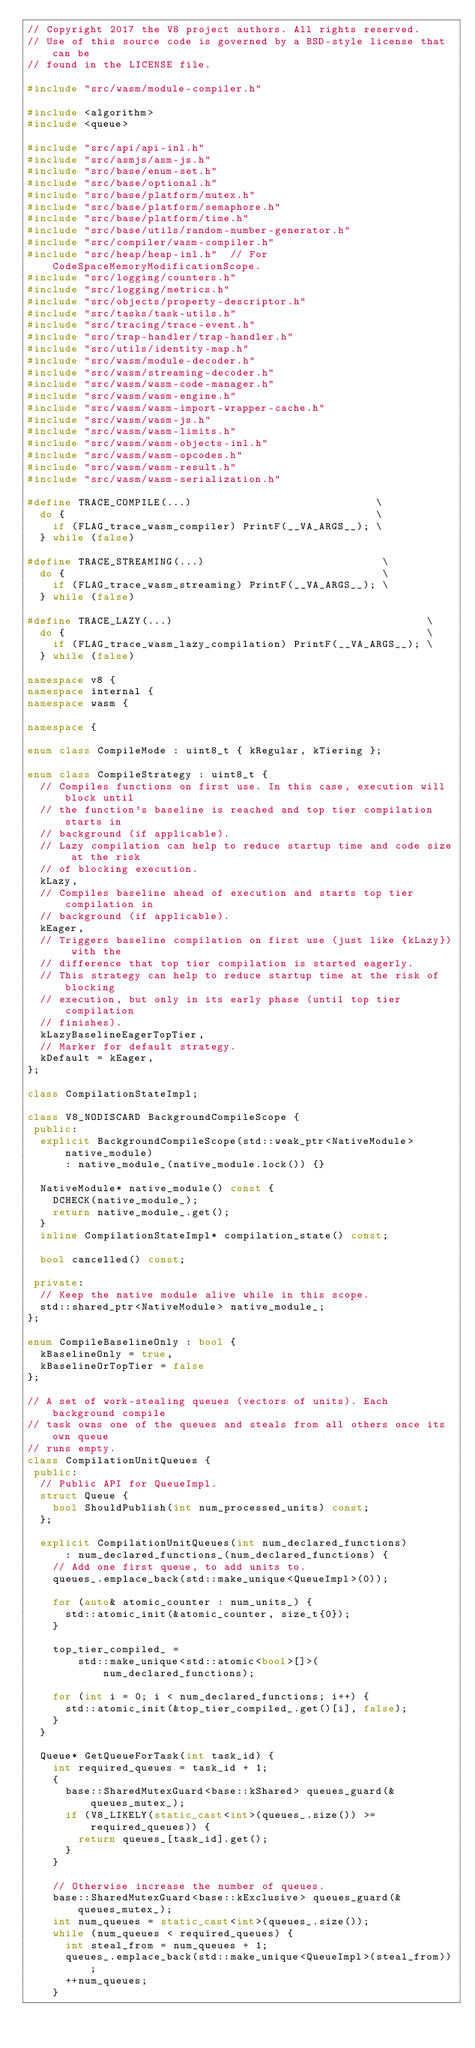<code> <loc_0><loc_0><loc_500><loc_500><_C++_>// Copyright 2017 the V8 project authors. All rights reserved.
// Use of this source code is governed by a BSD-style license that can be
// found in the LICENSE file.

#include "src/wasm/module-compiler.h"

#include <algorithm>
#include <queue>

#include "src/api/api-inl.h"
#include "src/asmjs/asm-js.h"
#include "src/base/enum-set.h"
#include "src/base/optional.h"
#include "src/base/platform/mutex.h"
#include "src/base/platform/semaphore.h"
#include "src/base/platform/time.h"
#include "src/base/utils/random-number-generator.h"
#include "src/compiler/wasm-compiler.h"
#include "src/heap/heap-inl.h"  // For CodeSpaceMemoryModificationScope.
#include "src/logging/counters.h"
#include "src/logging/metrics.h"
#include "src/objects/property-descriptor.h"
#include "src/tasks/task-utils.h"
#include "src/tracing/trace-event.h"
#include "src/trap-handler/trap-handler.h"
#include "src/utils/identity-map.h"
#include "src/wasm/module-decoder.h"
#include "src/wasm/streaming-decoder.h"
#include "src/wasm/wasm-code-manager.h"
#include "src/wasm/wasm-engine.h"
#include "src/wasm/wasm-import-wrapper-cache.h"
#include "src/wasm/wasm-js.h"
#include "src/wasm/wasm-limits.h"
#include "src/wasm/wasm-objects-inl.h"
#include "src/wasm/wasm-opcodes.h"
#include "src/wasm/wasm-result.h"
#include "src/wasm/wasm-serialization.h"

#define TRACE_COMPILE(...)                             \
  do {                                                 \
    if (FLAG_trace_wasm_compiler) PrintF(__VA_ARGS__); \
  } while (false)

#define TRACE_STREAMING(...)                            \
  do {                                                  \
    if (FLAG_trace_wasm_streaming) PrintF(__VA_ARGS__); \
  } while (false)

#define TRACE_LAZY(...)                                        \
  do {                                                         \
    if (FLAG_trace_wasm_lazy_compilation) PrintF(__VA_ARGS__); \
  } while (false)

namespace v8 {
namespace internal {
namespace wasm {

namespace {

enum class CompileMode : uint8_t { kRegular, kTiering };

enum class CompileStrategy : uint8_t {
  // Compiles functions on first use. In this case, execution will block until
  // the function's baseline is reached and top tier compilation starts in
  // background (if applicable).
  // Lazy compilation can help to reduce startup time and code size at the risk
  // of blocking execution.
  kLazy,
  // Compiles baseline ahead of execution and starts top tier compilation in
  // background (if applicable).
  kEager,
  // Triggers baseline compilation on first use (just like {kLazy}) with the
  // difference that top tier compilation is started eagerly.
  // This strategy can help to reduce startup time at the risk of blocking
  // execution, but only in its early phase (until top tier compilation
  // finishes).
  kLazyBaselineEagerTopTier,
  // Marker for default strategy.
  kDefault = kEager,
};

class CompilationStateImpl;

class V8_NODISCARD BackgroundCompileScope {
 public:
  explicit BackgroundCompileScope(std::weak_ptr<NativeModule> native_module)
      : native_module_(native_module.lock()) {}

  NativeModule* native_module() const {
    DCHECK(native_module_);
    return native_module_.get();
  }
  inline CompilationStateImpl* compilation_state() const;

  bool cancelled() const;

 private:
  // Keep the native module alive while in this scope.
  std::shared_ptr<NativeModule> native_module_;
};

enum CompileBaselineOnly : bool {
  kBaselineOnly = true,
  kBaselineOrTopTier = false
};

// A set of work-stealing queues (vectors of units). Each background compile
// task owns one of the queues and steals from all others once its own queue
// runs empty.
class CompilationUnitQueues {
 public:
  // Public API for QueueImpl.
  struct Queue {
    bool ShouldPublish(int num_processed_units) const;
  };

  explicit CompilationUnitQueues(int num_declared_functions)
      : num_declared_functions_(num_declared_functions) {
    // Add one first queue, to add units to.
    queues_.emplace_back(std::make_unique<QueueImpl>(0));

    for (auto& atomic_counter : num_units_) {
      std::atomic_init(&atomic_counter, size_t{0});
    }

    top_tier_compiled_ =
        std::make_unique<std::atomic<bool>[]>(num_declared_functions);

    for (int i = 0; i < num_declared_functions; i++) {
      std::atomic_init(&top_tier_compiled_.get()[i], false);
    }
  }

  Queue* GetQueueForTask(int task_id) {
    int required_queues = task_id + 1;
    {
      base::SharedMutexGuard<base::kShared> queues_guard(&queues_mutex_);
      if (V8_LIKELY(static_cast<int>(queues_.size()) >= required_queues)) {
        return queues_[task_id].get();
      }
    }

    // Otherwise increase the number of queues.
    base::SharedMutexGuard<base::kExclusive> queues_guard(&queues_mutex_);
    int num_queues = static_cast<int>(queues_.size());
    while (num_queues < required_queues) {
      int steal_from = num_queues + 1;
      queues_.emplace_back(std::make_unique<QueueImpl>(steal_from));
      ++num_queues;
    }
</code> 